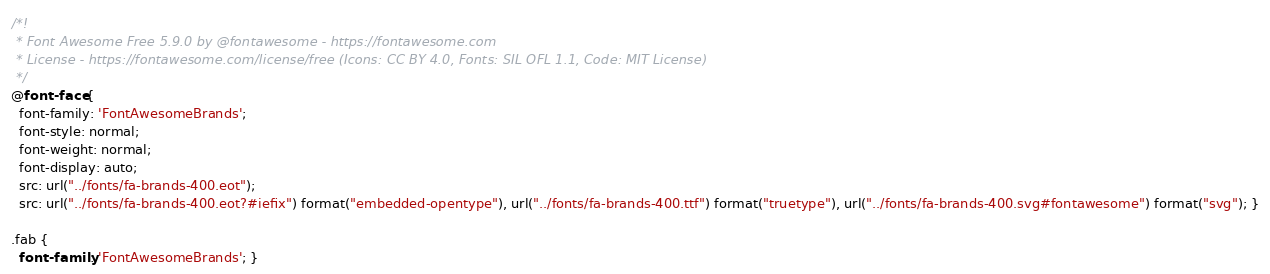Convert code to text. <code><loc_0><loc_0><loc_500><loc_500><_CSS_>/*!
 * Font Awesome Free 5.9.0 by @fontawesome - https://fontawesome.com
 * License - https://fontawesome.com/license/free (Icons: CC BY 4.0, Fonts: SIL OFL 1.1, Code: MIT License)
 */
@font-face {
  font-family: 'FontAwesomeBrands';
  font-style: normal;
  font-weight: normal;
  font-display: auto;
  src: url("../fonts/fa-brands-400.eot");
  src: url("../fonts/fa-brands-400.eot?#iefix") format("embedded-opentype"), url("../fonts/fa-brands-400.ttf") format("truetype"), url("../fonts/fa-brands-400.svg#fontawesome") format("svg"); }

.fab {
  font-family: 'FontAwesomeBrands'; }
</code> 